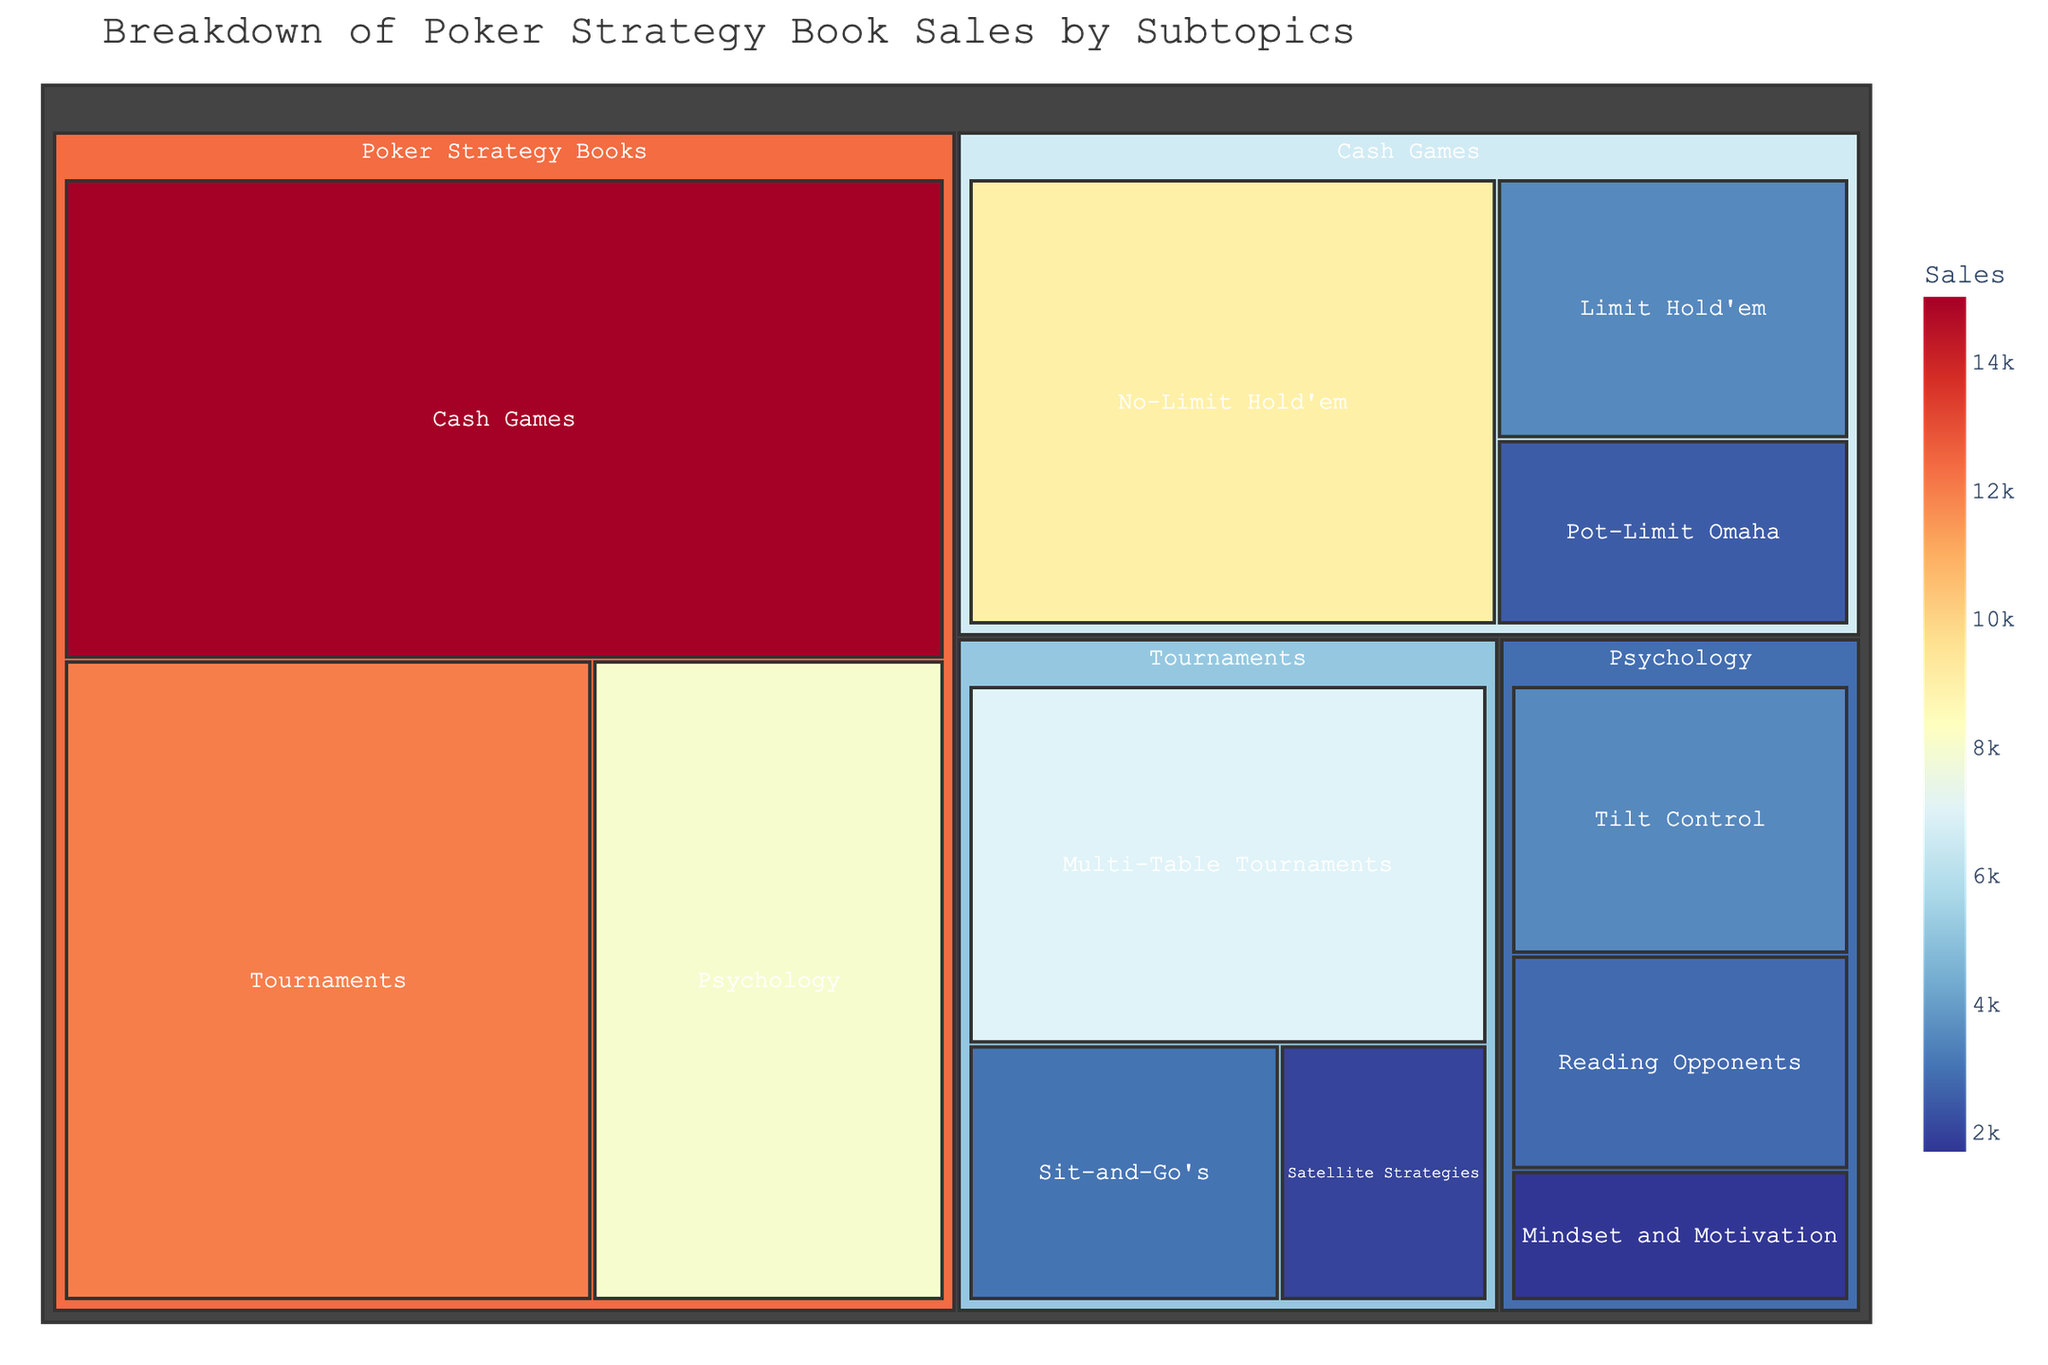What is the total sales value for Cash Games subtopics? The sales values for the subtopics under Cash Games are No-Limit Hold'em (9,000), Limit Hold'em (3,500), and Pot-Limit Omaha (2,500). Summing these values: 9000 + 3500 + 2500 = 15,000.
Answer: 15,000 Which subtopic has the highest sales? The treemap shows No-Limit Hold'em with a sales value of 9,000, which is the highest among all subtopics.
Answer: No-Limit Hold'em How do the sales of Tournaments subtopics compare to the sales of Psychology subtopics? The total sales for Tournaments subtopics are Multi-Table Tournaments (7,000), Sit-and-Go's (3,000), and Satellite Strategies (2,000), summing up to 12,000. The total sales for Psychology subtopics are Tilt Control (3,500), Reading Opponents (2,800), and Mindset and Motivation (1,700), summing up to 8,000. Comparatively, Tournaments subtopics have higher sales.
Answer: Tournaments subtopics have higher sales What are the sales values for each Psychology subtopic? The sales values for Psychology subtopics are Tilt Control (3,500), Reading Opponents (2,800), and Mindset and Motivation (1,700).
Answer: 3,500, 2,800, 1,700 Which subtopic has the lowest sales? Mindset and Motivation, part of the Psychology category, has the lowest sales value of 1,700.
Answer: Mindset and Motivation What is the difference in sales between No-Limit Hold'em and Multi-Table Tournaments? The sales of No-Limit Hold'em are 9,000, and the sales of Multi-Table Tournaments are 7,000. The difference is 9,000 - 7,000 = 2,000.
Answer: 2,000 How many subtopics are there under Poker Strategy Books? The treemap shows three main subtopics under Poker Strategy Books: Cash Games, Tournaments, and Psychology.
Answer: 3 What percentage of total Poker Strategy Book sales do Tournaments subtopics represent? First, sum the total sales for Poker Strategy Books: 15,000 (Cash Games) + 12,000 (Tournaments) + 8,000 (Psychology) = 35,000. Then, calculate the percentage: (12,000 / 35,000) * 100 ≈ 34.29%.
Answer: 34.29% What are the total sales for all Poker Strategy Books subtopics? Summing the total sales: Cash Games (15,000) + Tournaments (12,000) + Psychology (8,000) = 35,000.
Answer: 35,000 